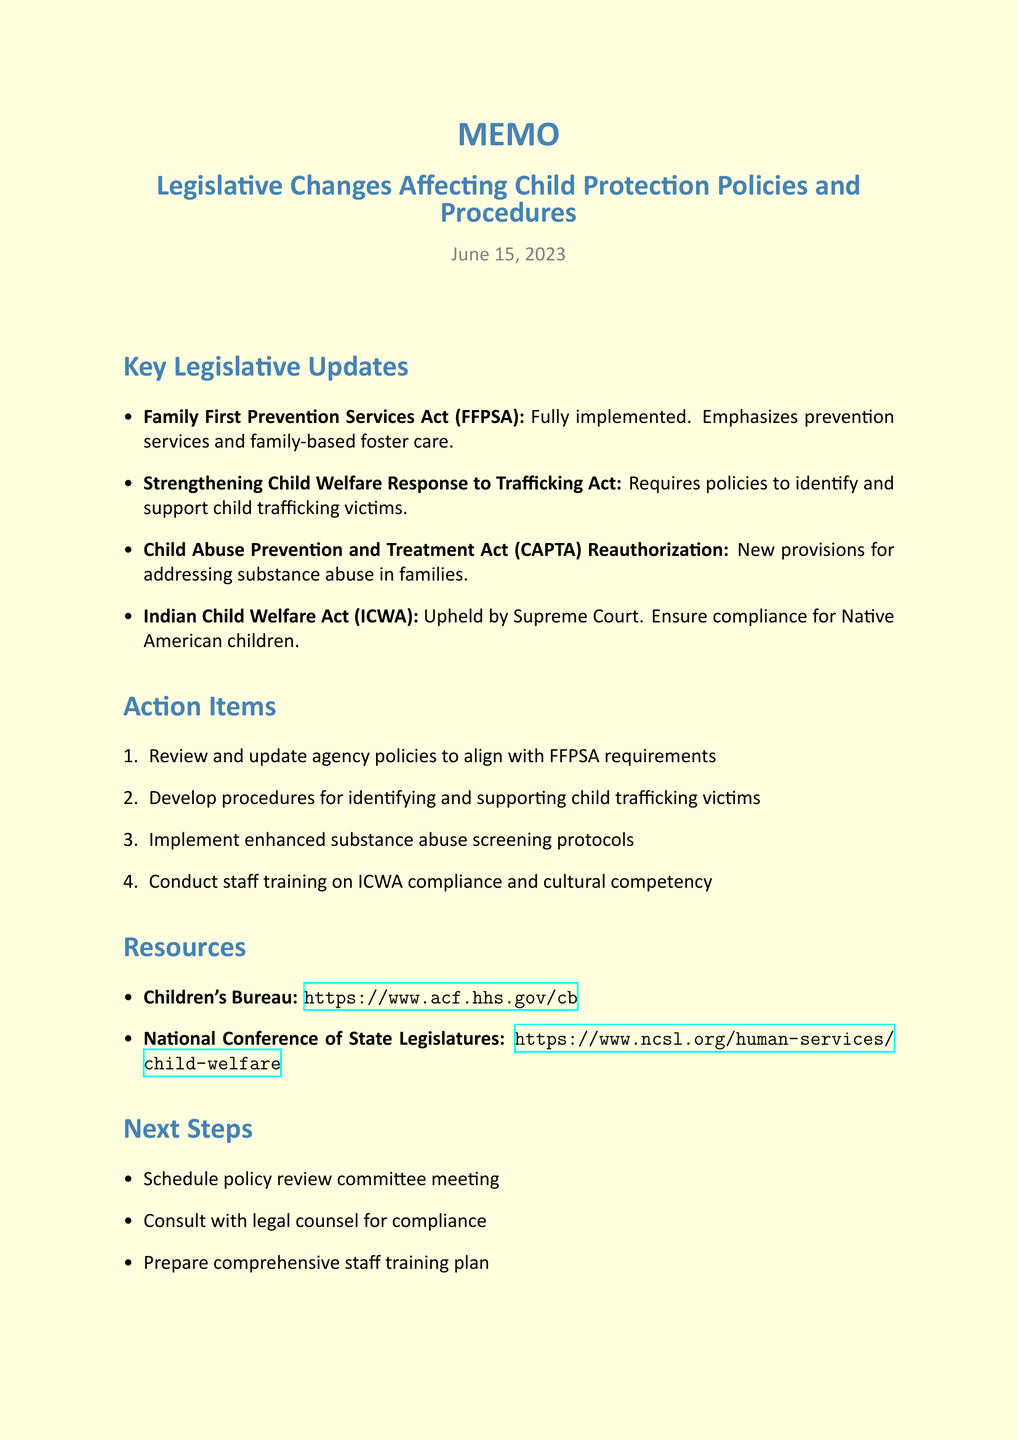What is the title of the memo? The title of the memo is explicitly stated at the beginning of the document.
Answer: Legislative Changes Affecting Child Protection Policies and Procedures When was the memo dated? The date of the memo is mentioned under the title section.
Answer: June 15, 2023 What act emphasizes prevention services? This act is listed in the key legislative updates section.
Answer: Family First Prevention Services Act (FFPSA) What are we required to implement enhanced protocols for? The related act specifies the area needing enhanced protocols, as mentioned in the action items.
Answer: Substance abuse screening Which act relates to child trafficking? The title of the relevant act is provided in the key legislative updates.
Answer: Strengthening Child Welfare Response to Trafficking Act What is one action item listed in the document? This is a direct quote from the action items section that outlines what needs to be done.
Answer: Review and update agency policies to align with FFPSA requirements What resource is mentioned for guidance on federal policies? The resource section provides the name and purpose of organizations that can help.
Answer: Children's Bureau What is required regarding the Indian Child Welfare Act (ICWA)? This is specifically addressed in the key points section of the memo.
Answer: Ensure compliance for Native American children How many next steps are outlined in the memo? The next steps section contains a numbered list which indicates the total.
Answer: Three 